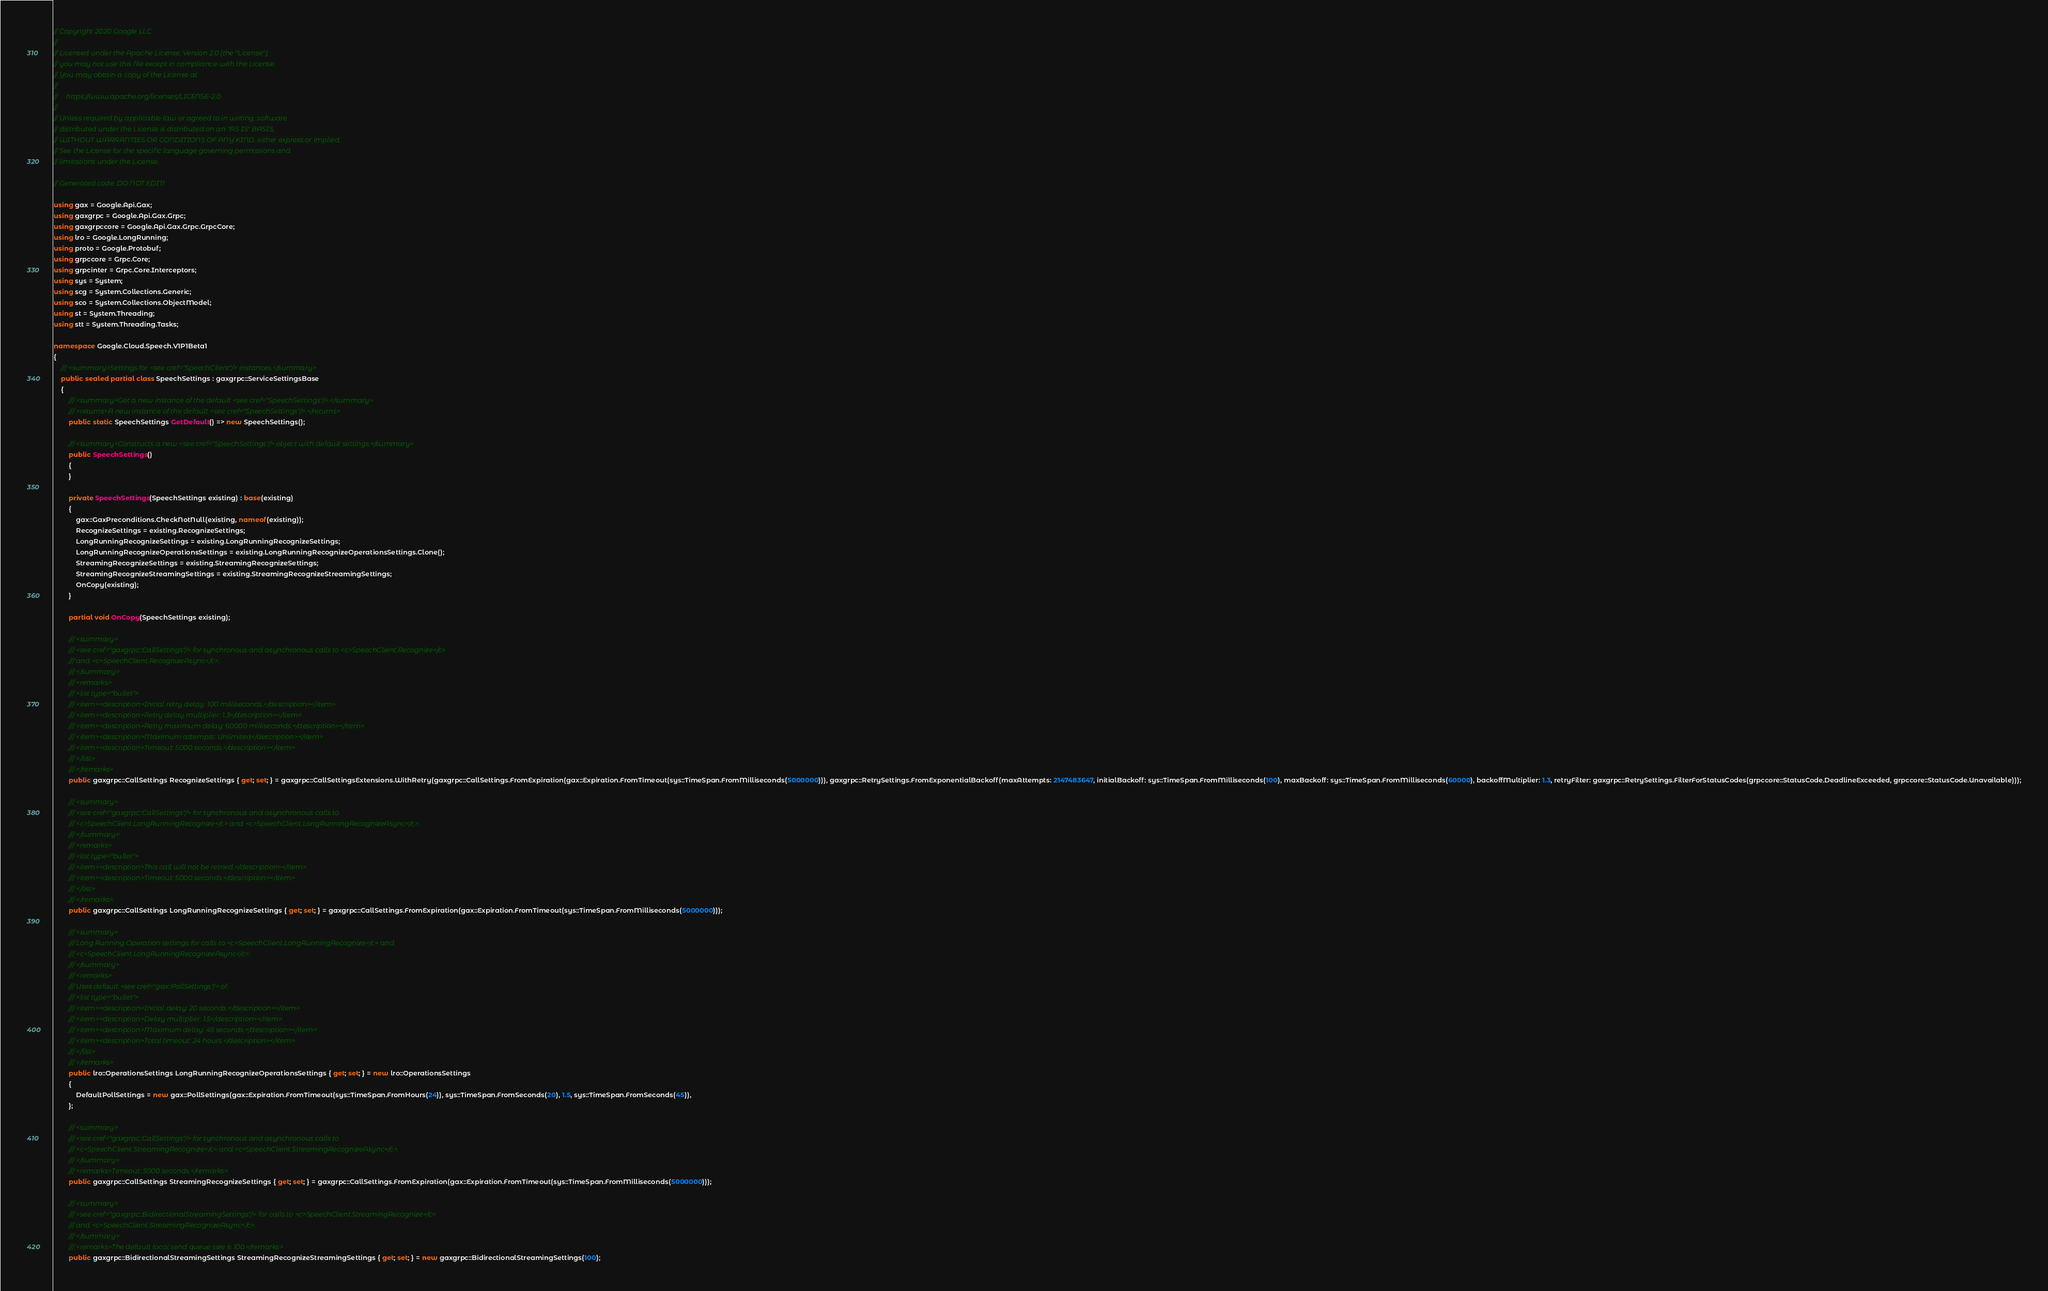<code> <loc_0><loc_0><loc_500><loc_500><_C#_>// Copyright 2020 Google LLC
//
// Licensed under the Apache License, Version 2.0 (the "License");
// you may not use this file except in compliance with the License.
// You may obtain a copy of the License at
//
//     https://www.apache.org/licenses/LICENSE-2.0
//
// Unless required by applicable law or agreed to in writing, software
// distributed under the License is distributed on an "AS IS" BASIS,
// WITHOUT WARRANTIES OR CONDITIONS OF ANY KIND, either express or implied.
// See the License for the specific language governing permissions and
// limitations under the License.

// Generated code. DO NOT EDIT!

using gax = Google.Api.Gax;
using gaxgrpc = Google.Api.Gax.Grpc;
using gaxgrpccore = Google.Api.Gax.Grpc.GrpcCore;
using lro = Google.LongRunning;
using proto = Google.Protobuf;
using grpccore = Grpc.Core;
using grpcinter = Grpc.Core.Interceptors;
using sys = System;
using scg = System.Collections.Generic;
using sco = System.Collections.ObjectModel;
using st = System.Threading;
using stt = System.Threading.Tasks;

namespace Google.Cloud.Speech.V1P1Beta1
{
    /// <summary>Settings for <see cref="SpeechClient"/> instances.</summary>
    public sealed partial class SpeechSettings : gaxgrpc::ServiceSettingsBase
    {
        /// <summary>Get a new instance of the default <see cref="SpeechSettings"/>.</summary>
        /// <returns>A new instance of the default <see cref="SpeechSettings"/>.</returns>
        public static SpeechSettings GetDefault() => new SpeechSettings();

        /// <summary>Constructs a new <see cref="SpeechSettings"/> object with default settings.</summary>
        public SpeechSettings()
        {
        }

        private SpeechSettings(SpeechSettings existing) : base(existing)
        {
            gax::GaxPreconditions.CheckNotNull(existing, nameof(existing));
            RecognizeSettings = existing.RecognizeSettings;
            LongRunningRecognizeSettings = existing.LongRunningRecognizeSettings;
            LongRunningRecognizeOperationsSettings = existing.LongRunningRecognizeOperationsSettings.Clone();
            StreamingRecognizeSettings = existing.StreamingRecognizeSettings;
            StreamingRecognizeStreamingSettings = existing.StreamingRecognizeStreamingSettings;
            OnCopy(existing);
        }

        partial void OnCopy(SpeechSettings existing);

        /// <summary>
        /// <see cref="gaxgrpc::CallSettings"/> for synchronous and asynchronous calls to <c>SpeechClient.Recognize</c>
        /// and <c>SpeechClient.RecognizeAsync</c>.
        /// </summary>
        /// <remarks>
        /// <list type="bullet">
        /// <item><description>Initial retry delay: 100 milliseconds.</description></item>
        /// <item><description>Retry delay multiplier: 1.3</description></item>
        /// <item><description>Retry maximum delay: 60000 milliseconds.</description></item>
        /// <item><description>Maximum attempts: Unlimited</description></item>
        /// <item><description>Timeout: 5000 seconds.</description></item>
        /// </list>
        /// </remarks>
        public gaxgrpc::CallSettings RecognizeSettings { get; set; } = gaxgrpc::CallSettingsExtensions.WithRetry(gaxgrpc::CallSettings.FromExpiration(gax::Expiration.FromTimeout(sys::TimeSpan.FromMilliseconds(5000000))), gaxgrpc::RetrySettings.FromExponentialBackoff(maxAttempts: 2147483647, initialBackoff: sys::TimeSpan.FromMilliseconds(100), maxBackoff: sys::TimeSpan.FromMilliseconds(60000), backoffMultiplier: 1.3, retryFilter: gaxgrpc::RetrySettings.FilterForStatusCodes(grpccore::StatusCode.DeadlineExceeded, grpccore::StatusCode.Unavailable)));

        /// <summary>
        /// <see cref="gaxgrpc::CallSettings"/> for synchronous and asynchronous calls to
        /// <c>SpeechClient.LongRunningRecognize</c> and <c>SpeechClient.LongRunningRecognizeAsync</c>.
        /// </summary>
        /// <remarks>
        /// <list type="bullet">
        /// <item><description>This call will not be retried.</description></item>
        /// <item><description>Timeout: 5000 seconds.</description></item>
        /// </list>
        /// </remarks>
        public gaxgrpc::CallSettings LongRunningRecognizeSettings { get; set; } = gaxgrpc::CallSettings.FromExpiration(gax::Expiration.FromTimeout(sys::TimeSpan.FromMilliseconds(5000000)));

        /// <summary>
        /// Long Running Operation settings for calls to <c>SpeechClient.LongRunningRecognize</c> and
        /// <c>SpeechClient.LongRunningRecognizeAsync</c>.
        /// </summary>
        /// <remarks>
        /// Uses default <see cref="gax::PollSettings"/> of:
        /// <list type="bullet">
        /// <item><description>Initial delay: 20 seconds.</description></item>
        /// <item><description>Delay multiplier: 1.5</description></item>
        /// <item><description>Maximum delay: 45 seconds.</description></item>
        /// <item><description>Total timeout: 24 hours.</description></item>
        /// </list>
        /// </remarks>
        public lro::OperationsSettings LongRunningRecognizeOperationsSettings { get; set; } = new lro::OperationsSettings
        {
            DefaultPollSettings = new gax::PollSettings(gax::Expiration.FromTimeout(sys::TimeSpan.FromHours(24)), sys::TimeSpan.FromSeconds(20), 1.5, sys::TimeSpan.FromSeconds(45)),
        };

        /// <summary>
        /// <see cref="gaxgrpc::CallSettings"/> for synchronous and asynchronous calls to
        /// <c>SpeechClient.StreamingRecognize</c> and <c>SpeechClient.StreamingRecognizeAsync</c>.
        /// </summary>
        /// <remarks>Timeout: 5000 seconds.</remarks>
        public gaxgrpc::CallSettings StreamingRecognizeSettings { get; set; } = gaxgrpc::CallSettings.FromExpiration(gax::Expiration.FromTimeout(sys::TimeSpan.FromMilliseconds(5000000)));

        /// <summary>
        /// <see cref="gaxgrpc::BidirectionalStreamingSettings"/> for calls to <c>SpeechClient.StreamingRecognize</c>
        /// and <c>SpeechClient.StreamingRecognizeAsync</c>.
        /// </summary>
        /// <remarks>The default local send queue size is 100.</remarks>
        public gaxgrpc::BidirectionalStreamingSettings StreamingRecognizeStreamingSettings { get; set; } = new gaxgrpc::BidirectionalStreamingSettings(100);
</code> 